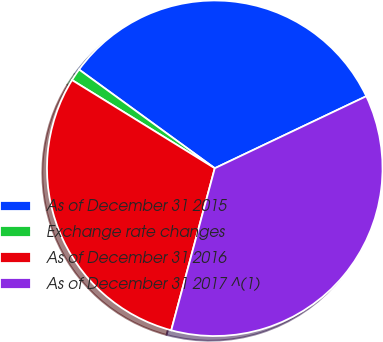Convert chart to OTSL. <chart><loc_0><loc_0><loc_500><loc_500><pie_chart><fcel>As of December 31 2015<fcel>Exchange rate changes<fcel>As of December 31 2016<fcel>As of December 31 2017 ^(1)<nl><fcel>32.93%<fcel>1.2%<fcel>29.63%<fcel>36.24%<nl></chart> 